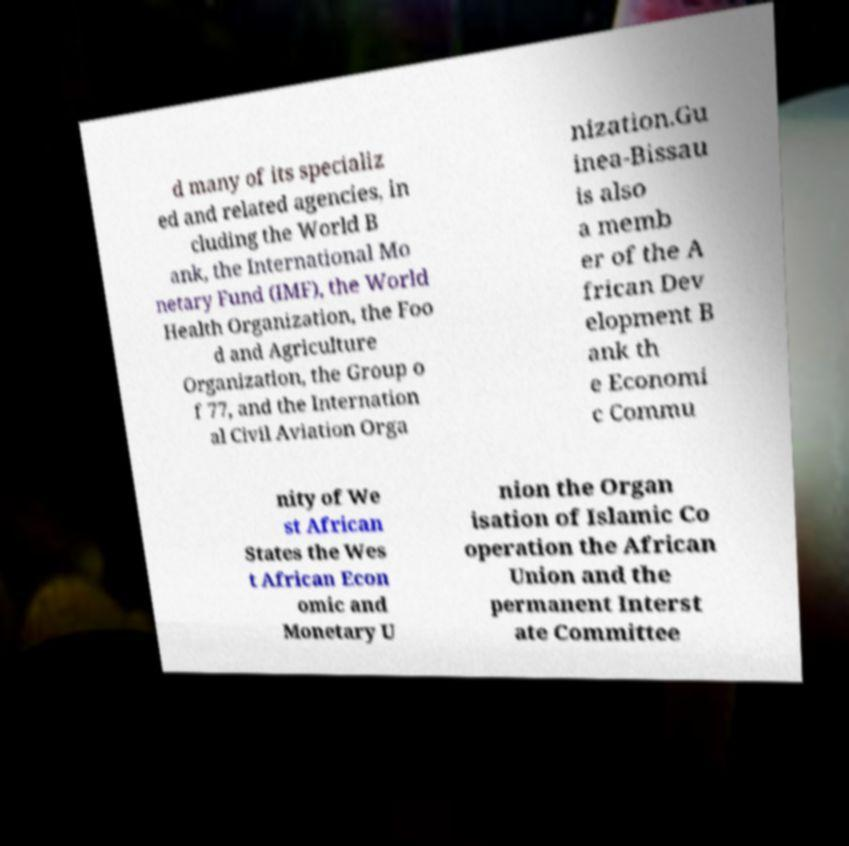Could you assist in decoding the text presented in this image and type it out clearly? d many of its specializ ed and related agencies, in cluding the World B ank, the International Mo netary Fund (IMF), the World Health Organization, the Foo d and Agriculture Organization, the Group o f 77, and the Internation al Civil Aviation Orga nization.Gu inea-Bissau is also a memb er of the A frican Dev elopment B ank th e Economi c Commu nity of We st African States the Wes t African Econ omic and Monetary U nion the Organ isation of Islamic Co operation the African Union and the permanent Interst ate Committee 